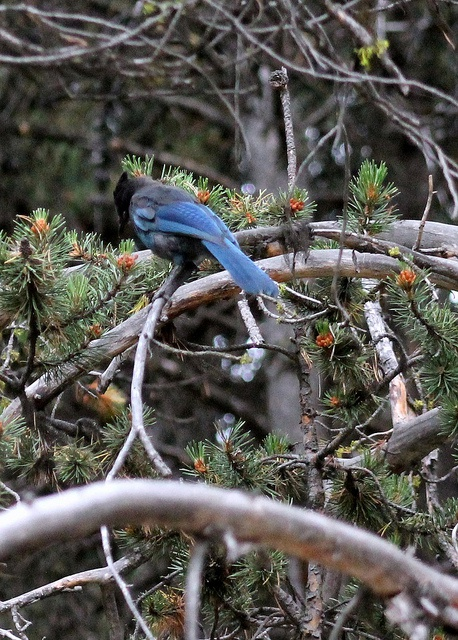Describe the objects in this image and their specific colors. I can see a bird in black and gray tones in this image. 